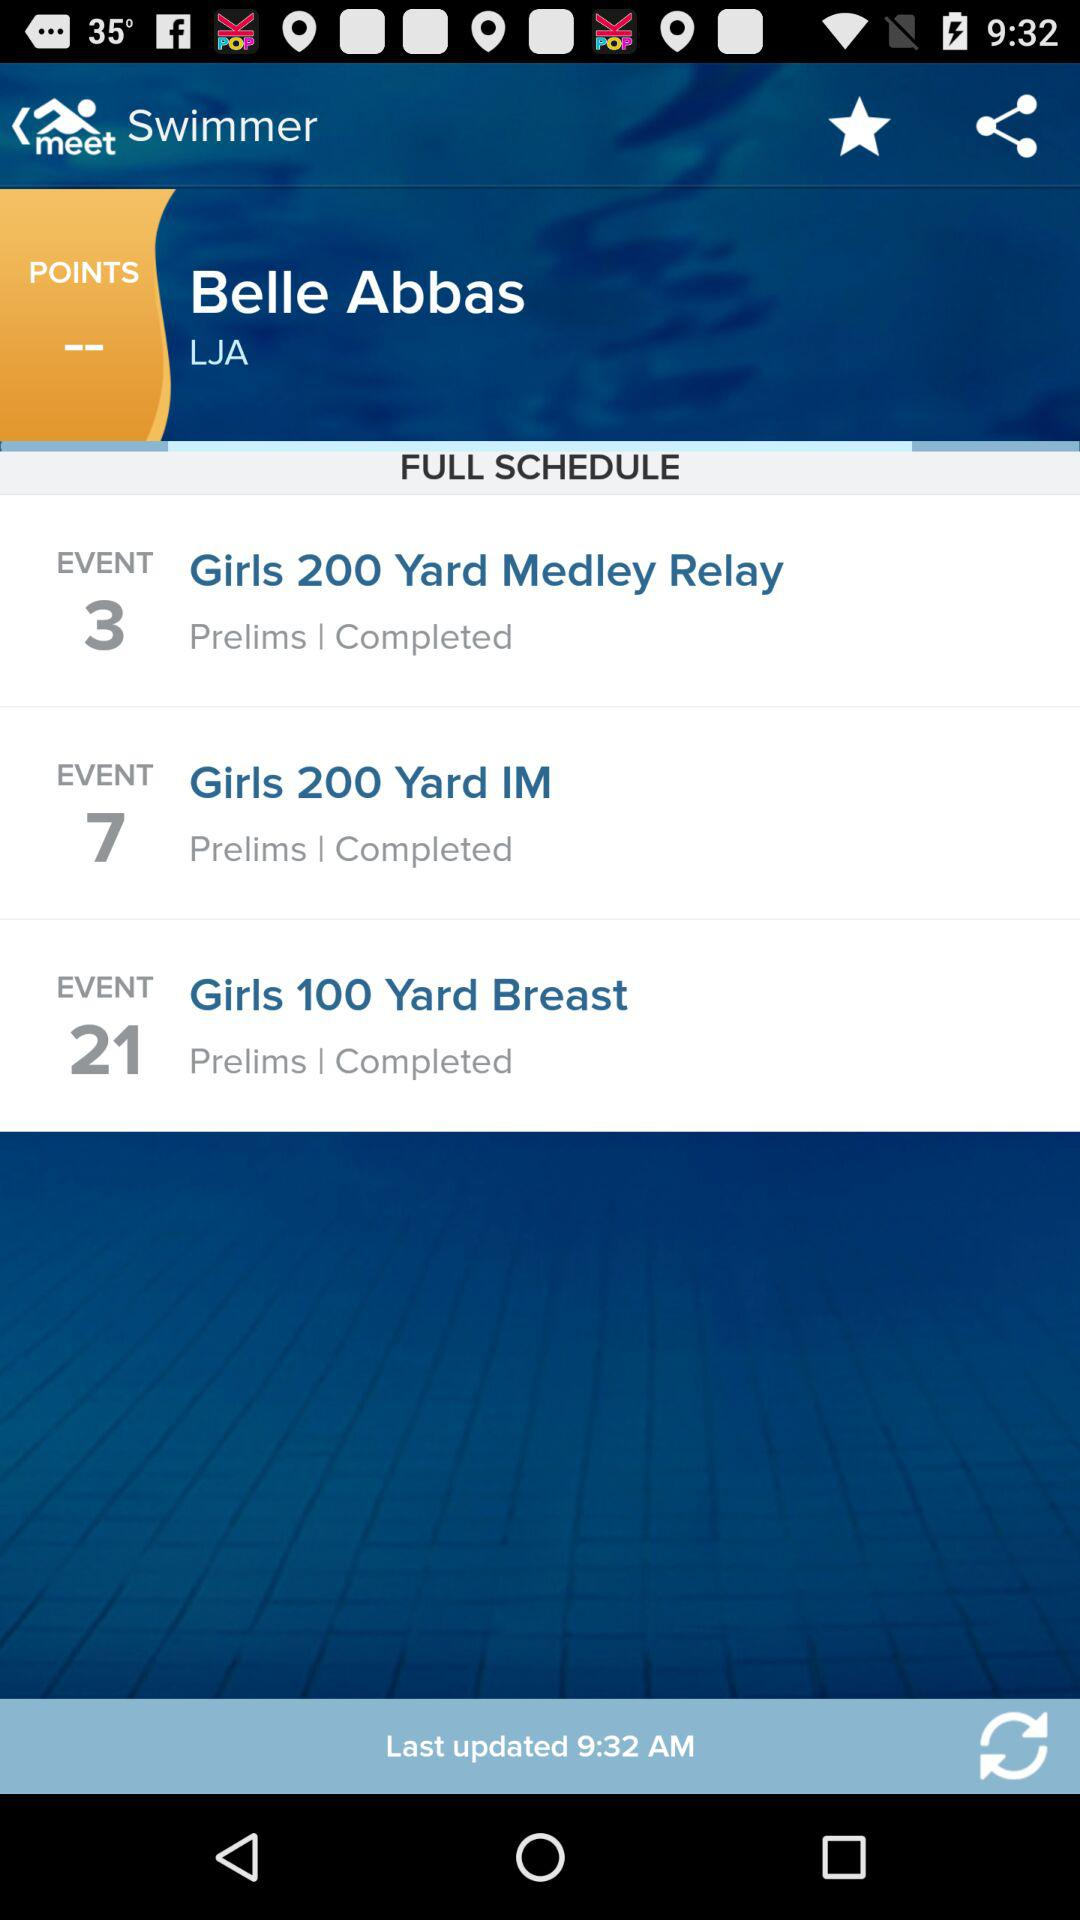What is the event number for "Girls 200 Yard IM"? The event number for "Girls 200 Yard IM" is 7. 